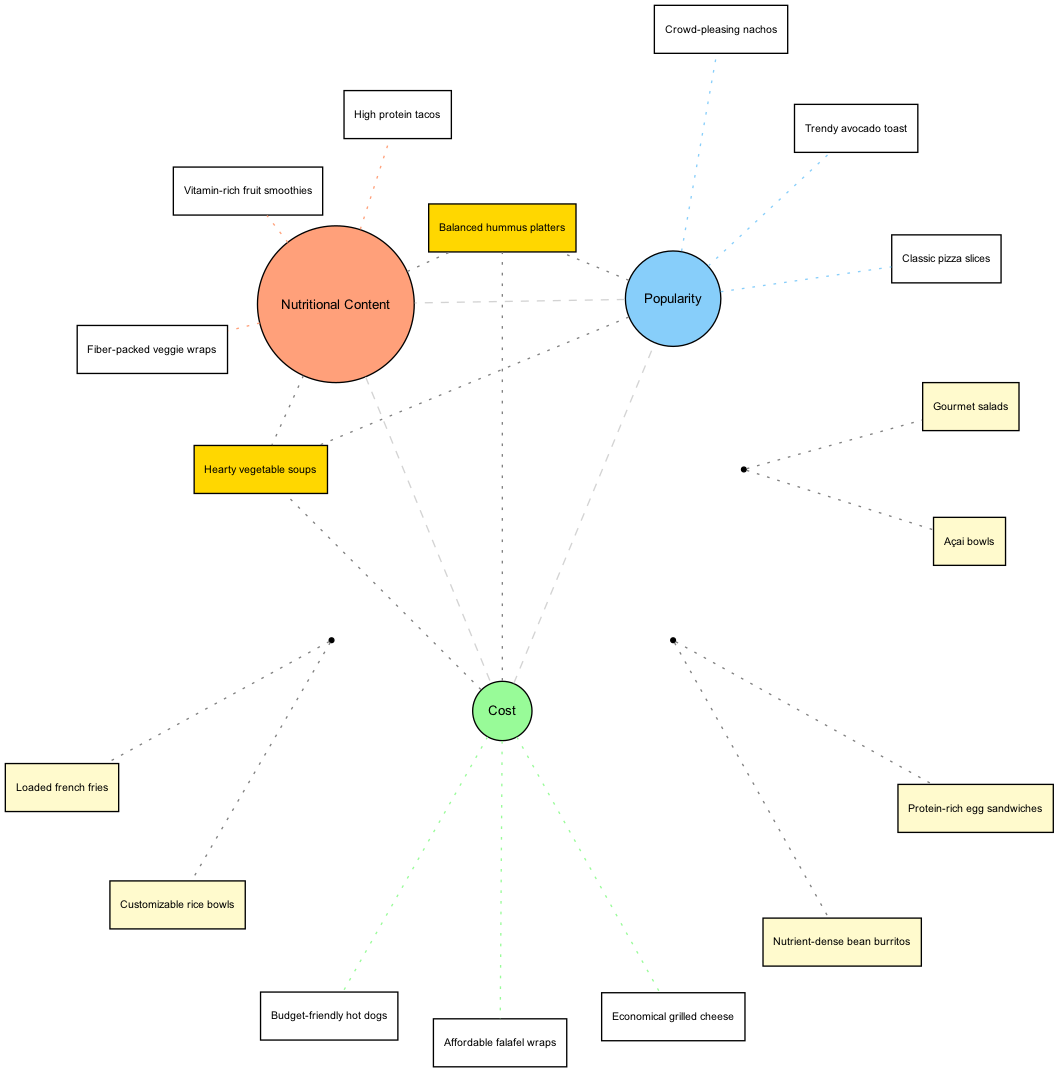What are three items listed under Nutritional Content? The set labeled "Nutritional Content" includes the items: "High protein tacos," "Vitamin-rich fruit smoothies," and "Fiber-packed veggie wraps." These are explicitly listed as part of that set in the diagram.
Answer: High protein tacos, Vitamin-rich fruit smoothies, Fiber-packed veggie wraps Which item is placed at the intersection of Cost and Popularity? The intersection of the sets "Cost" and "Popularity" includes the items: "Loaded french fries" and "Customizable rice bowls." These items appear specifically in the overlapping region of these two circles.
Answer: Loaded french fries, Customizable rice bowls How many items are there in the Nutritional Content set? The "Nutritional Content" set consists of three items: "High protein tacos," "Vitamin-rich fruit smoothies," and "Fiber-packed veggie wraps." This is directly counted from the listed items in that specific set in the diagram.
Answer: 3 Which item is common across all three sets? The item that exists in the intersection of "Nutritional Content," "Cost," and "Popularity" is "Hearty vegetable soups" and "Balanced hummus platters." This is observed as it is part of the overlap among all three sets in the diagram.
Answer: Hearty vegetable soups, Balanced hummus platters What color is used to represent Cost in the diagram? The set labeled "Cost" is represented in light green color (#98FB98), as specified in the color definitions for each set in the diagram.
Answer: Light green How many items are placed only in the Cost set? The "Cost" set has three items: "Budget-friendly hot dogs," "Affordable falafel wraps," and "Economical grilled cheese," but none of these are repeated in other sets, so all are exclusive to Cost.
Answer: 3 Which intersection contains a nutrient-dense bean burrito? The item "Nutrient-dense bean burritos" is found at the intersection of "Nutritional Content" and "Cost." This information can be tracked by looking at what items belong in the overlapping area of those two circles.
Answer: Nutritional Content, Cost Is "Açai bowls" more popular or nutritional according to the diagram? "Açai bowls" is listed in the intersection of "Nutritional Content" and "Popularity," indicating that it holds significance in both categories, but it does not appear in Cost. It shows it can be considered equally as both popular and nutritional, requiring evaluation from both dimensions to determine its placement.
Answer: Equally popular and nutritional 